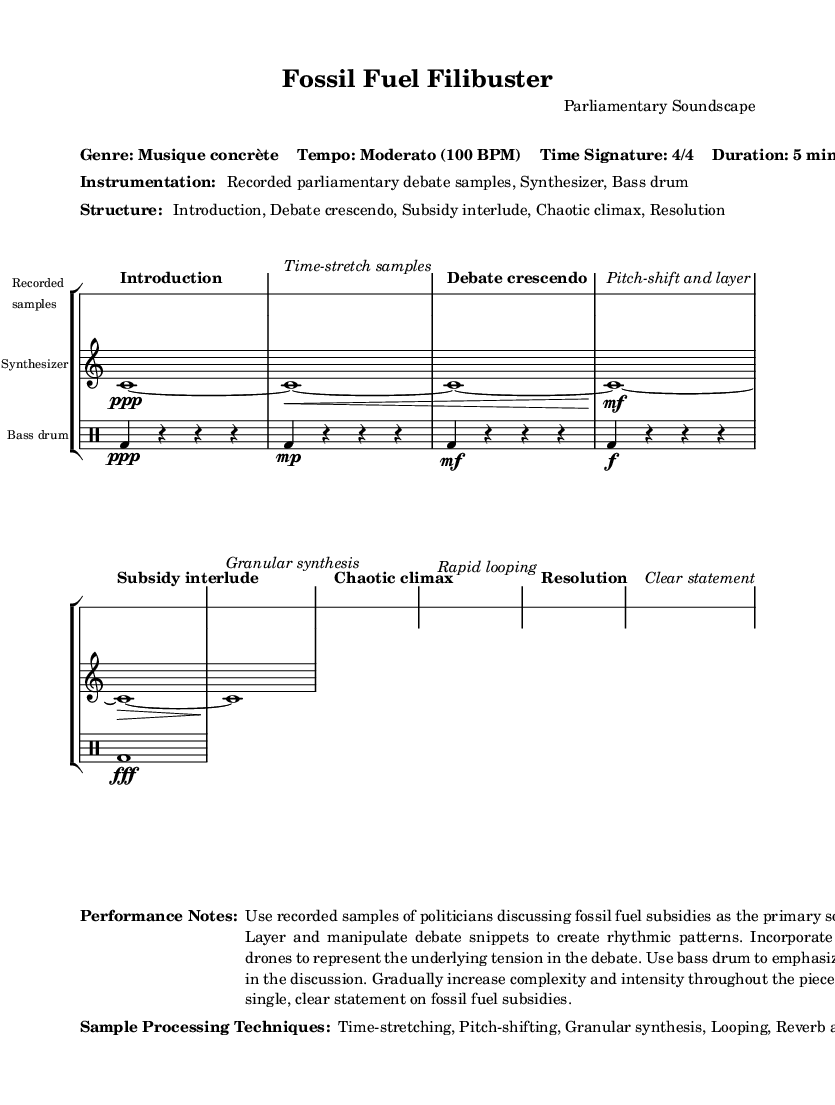What is the tempo of this piece? The sheet music states the tempo as "Moderato" and specifies a tempo marking of 100 BPM. Hence, the tempo of the piece is indicated clearly at the beginning.
Answer: Moderato (100 BPM) What is the time signature of this music? The time signature is notated explicitly in the structure of the piece, which is stated as "4/4." This means each measure contains four beats, and the quarter note receives one beat.
Answer: 4/4 What type of music genre is represented here? The genre is explicitly identified in the markup at the beginning of the score. It is labeled as "Musique concrète," which is distinctively characterized by the use of recorded sounds and sampling.
Answer: Musique concrète What instruments are featured in this piece? The instrumentation is listed in the markup section of the score where it outlines "Recorded parliamentary debate samples, Synthesizer, Bass drum." These are the sound sources used in the composition.
Answer: Recorded parliamentary debate samples, Synthesizer, Bass drum What is the structure of the piece? The structure is detailed in the markup, which lists sections such as "Introduction, Debate crescendo, Subsidy interlude, Chaotic climax, Resolution." This provides a clear outline of the piece's organization.
Answer: Introduction, Debate crescendo, Subsidy interlude, Chaotic climax, Resolution How does the piece begin? The beginning of the piece is introduced as "Introduction" in the score. This indicates where the initial sounds are introduced, and it also suggests the overall theme of the work is established here.
Answer: Introduction What processing techniques are used in the music? The sample processing techniques are mentioned in the markup section. It includes techniques such as "Time-stretching, Pitch-shifting, Granular synthesis, Looping, Reverb and delay effects," indicating the methods used to manipulate the recorded sounds.
Answer: Time-stretching, Pitch-shifting, Granular synthesis, Looping, Reverb and delay effects 